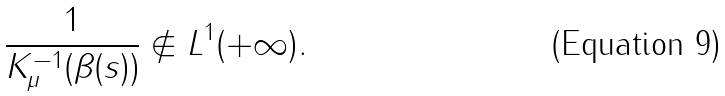Convert formula to latex. <formula><loc_0><loc_0><loc_500><loc_500>\frac { 1 } { K _ { \mu } ^ { - 1 } ( \beta ( s ) ) } \not \in L ^ { 1 } ( + \infty ) .</formula> 